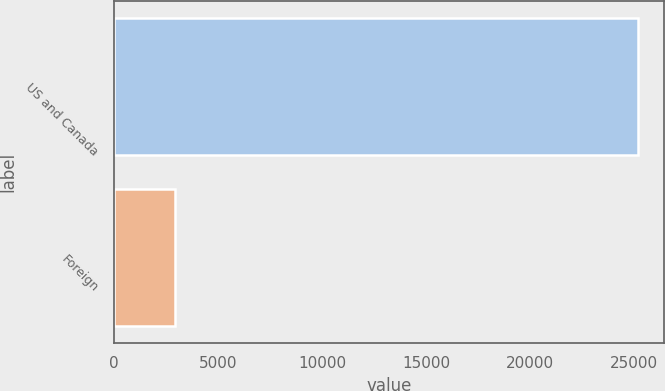Convert chart. <chart><loc_0><loc_0><loc_500><loc_500><bar_chart><fcel>US and Canada<fcel>Foreign<nl><fcel>25156<fcel>2955<nl></chart> 